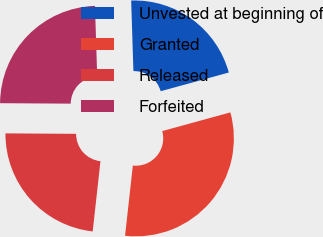Convert chart to OTSL. <chart><loc_0><loc_0><loc_500><loc_500><pie_chart><fcel>Unvested at beginning of<fcel>Granted<fcel>Released<fcel>Forfeited<nl><fcel>21.24%<fcel>31.02%<fcel>23.35%<fcel>24.39%<nl></chart> 